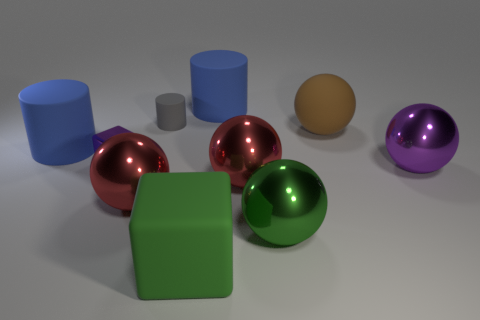Are there any metallic balls in front of the big rubber ball?
Your answer should be very brief. Yes. Are there the same number of large metallic objects that are on the right side of the green ball and big brown things?
Provide a short and direct response. Yes. What size is the other object that is the same shape as the tiny purple shiny object?
Provide a succinct answer. Large. Is the shape of the small matte thing the same as the rubber object that is in front of the tiny cube?
Your answer should be very brief. No. There is a gray object that is behind the big blue rubber thing in front of the tiny cylinder; what is its size?
Give a very brief answer. Small. Are there the same number of big green blocks to the right of the brown object and brown matte balls that are in front of the green shiny sphere?
Make the answer very short. Yes. There is another large matte thing that is the same shape as the large purple object; what color is it?
Provide a short and direct response. Brown. What number of big balls have the same color as the shiny block?
Ensure brevity in your answer.  1. Does the big blue object to the right of the green block have the same shape as the small rubber object?
Your response must be concise. Yes. What is the shape of the red metallic thing that is left of the large green matte cube to the right of the big object to the left of the purple cube?
Your answer should be compact. Sphere. 